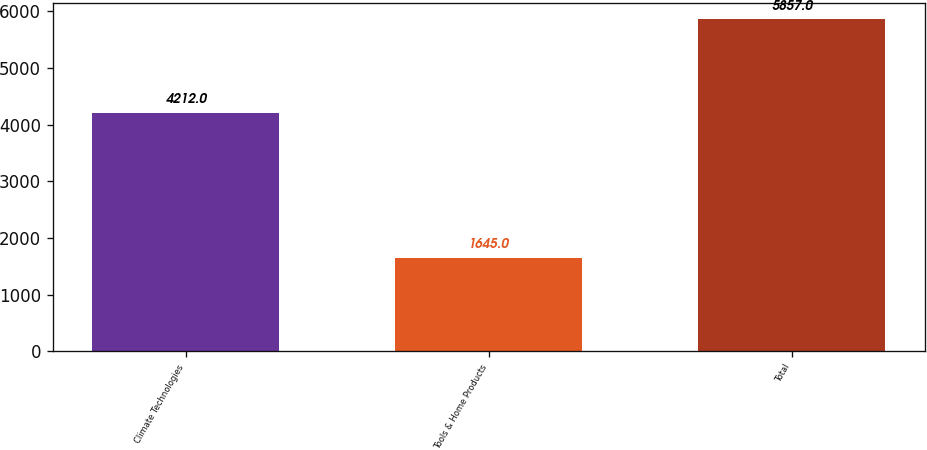Convert chart to OTSL. <chart><loc_0><loc_0><loc_500><loc_500><bar_chart><fcel>Climate Technologies<fcel>Tools & Home Products<fcel>Total<nl><fcel>4212<fcel>1645<fcel>5857<nl></chart> 